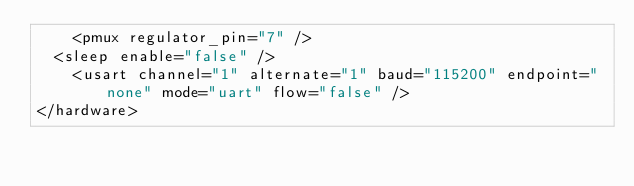<code> <loc_0><loc_0><loc_500><loc_500><_XML_>    <pmux regulator_pin="7" />
	<sleep enable="false" />
    <usart channel="1" alternate="1" baud="115200" endpoint="none" mode="uart" flow="false" />
</hardware>
</code> 